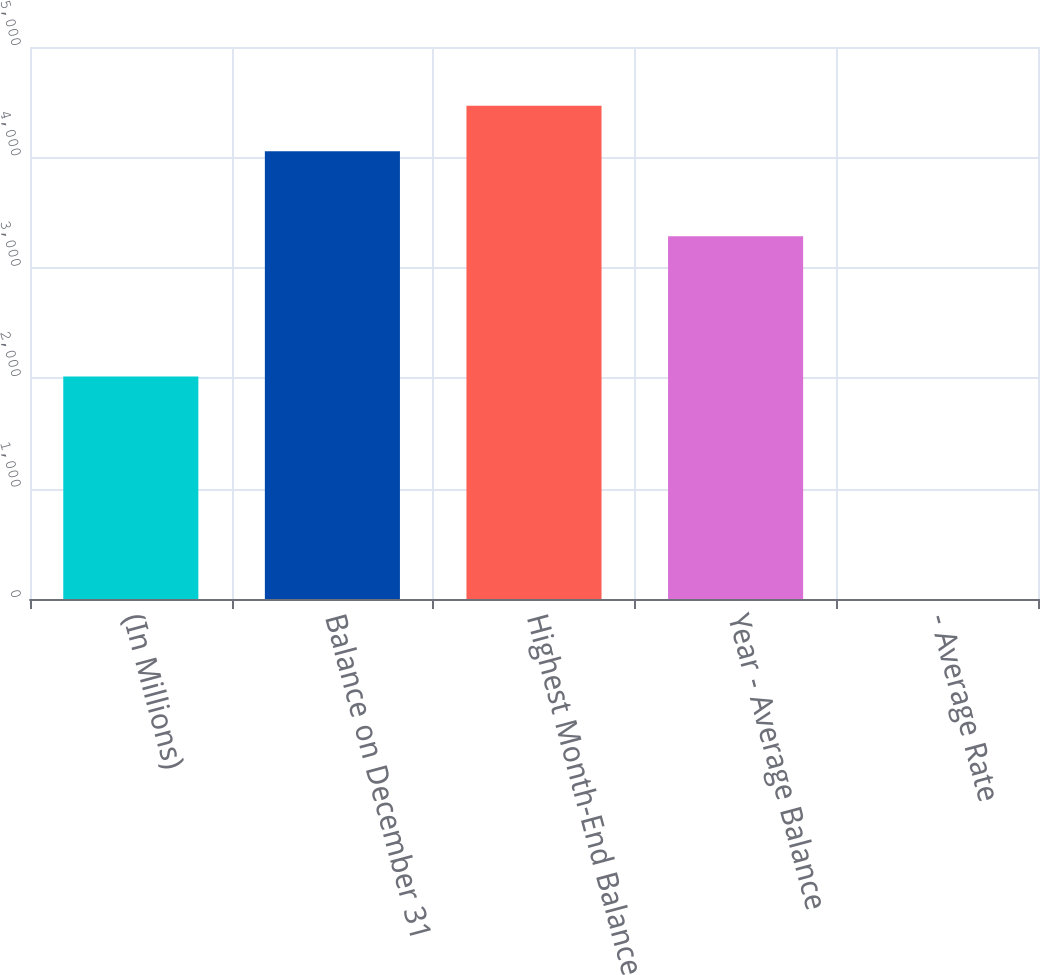<chart> <loc_0><loc_0><loc_500><loc_500><bar_chart><fcel>(In Millions)<fcel>Balance on December 31<fcel>Highest Month-End Balance<fcel>Year - Average Balance<fcel>- Average Rate<nl><fcel>2015<fcel>4055.1<fcel>4467.4<fcel>3284.9<fcel>0.15<nl></chart> 